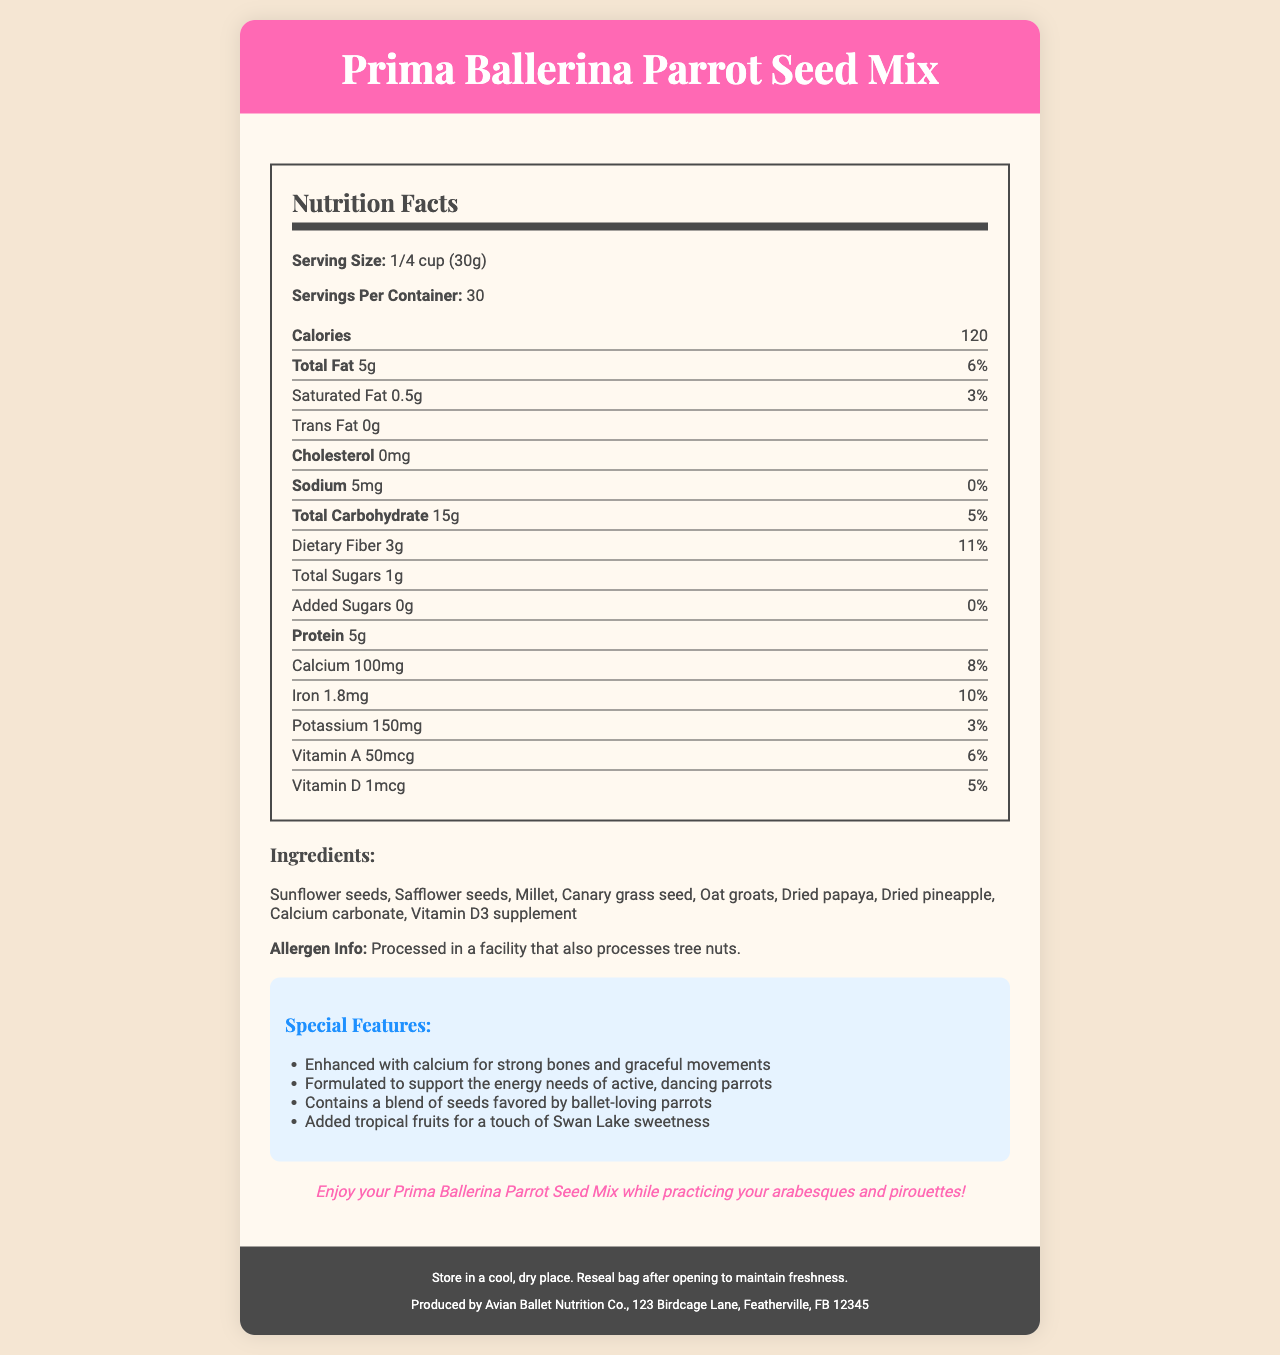what is the serving size? The document lists the serving size as 1/4 cup (30g) in the Nutrition Facts section.
Answer: 1/4 cup (30g) how many calories are there per serving? The Nutrition Facts section specifies that there are 120 calories per serving.
Answer: 120 what is the amount of saturated fat per serving? The amount of saturated fat per serving is listed as 0.5g in the Nutrition Facts section.
Answer: 0.5g what ingredients are included in the Prima Ballerina Parrot Seed Mix? The document lists these ingredients under the Ingredients section.
Answer: Sunflower seeds, Safflower seeds, Millet, Canary grass seed, Oat groats, Dried papaya, Dried pineapple, Calcium carbonate, Vitamin D3 supplement how much calcium is in each serving? The document states that each serving contains 100mg of calcium in the Nutrition Facts section.
Answer: 100mg is this product processed in a facility that also processes tree nuts? The Ingredients section includes allergen information indicating that the product is processed in a facility that also processes tree nuts.
Answer: Yes which of the following vitamins are included in the Prima Ballerina Parrot Seed Mix? A. Vitamin B12 B. Vitamin D C. Vitamin C D. Vitamin A The Nutrition Facts section shows that vitamin A and vitamin D are included. Vitamin B12 and vitamin C are not mentioned.
Answer: B and D what is the daily value percentage of iron per serving? The Nutrition Facts section lists the daily value percentage for iron as 10%.
Answer: 10% which of the following features is NOT listed as a special feature of this product? I. Enhanced with calcium II. Formulated for energy III. Contains tropical fruits IV. Gluten-free The Special Features section lists the first three features, but there is no mention of the product being gluten-free.
Answer: IV. Gluten-free is there any trans fat in the Prima Ballerina Parrot Seed Mix? The Nutrition Facts section clearly states that there is 0g of trans fat per serving.
Answer: No summarize the main purpose of the Prima Ballerina Parrot Seed Mix. The product is meant to provide nutrition that supports active, dancing parrots, featuring ingredients favored by these parrots and adding a touch of sweetness from tropical fruits. Special features highlight the benefits related to bone strength and energy provision.
Answer: The Prima Ballerina Parrot Seed Mix is a specially formulated birdseed mix designed to support the energy needs and promote strong bones in ballet-loving parrots. It includes a mix of seeds and dried tropical fruits and is enriched with calcium and vitamin D. what is the address of the manufacturer? The Manufacturer Info section at the bottom of the document lists the full address of the Avian Ballet Nutrition Co.
Answer: 123 Birdcage Lane, Featherville, FB 12345 how much dietary fiber is there per serving, and what is its daily value percentage? The Nutrition Facts section states that there are 3g of dietary fiber per serving, which is 11% of the daily value.
Answer: 3g; 11% what is the storage instruction for this product? The document's footer contains the storage instructions.
Answer: Store in a cool, dry place. Reseal bag after opening to maintain freshness. what is the song you should practice while enjoying this seed mix? The document provides dancing tips but does not specify any particular song that should be practiced while enjoying the seed mix.
Answer: Cannot be determined 